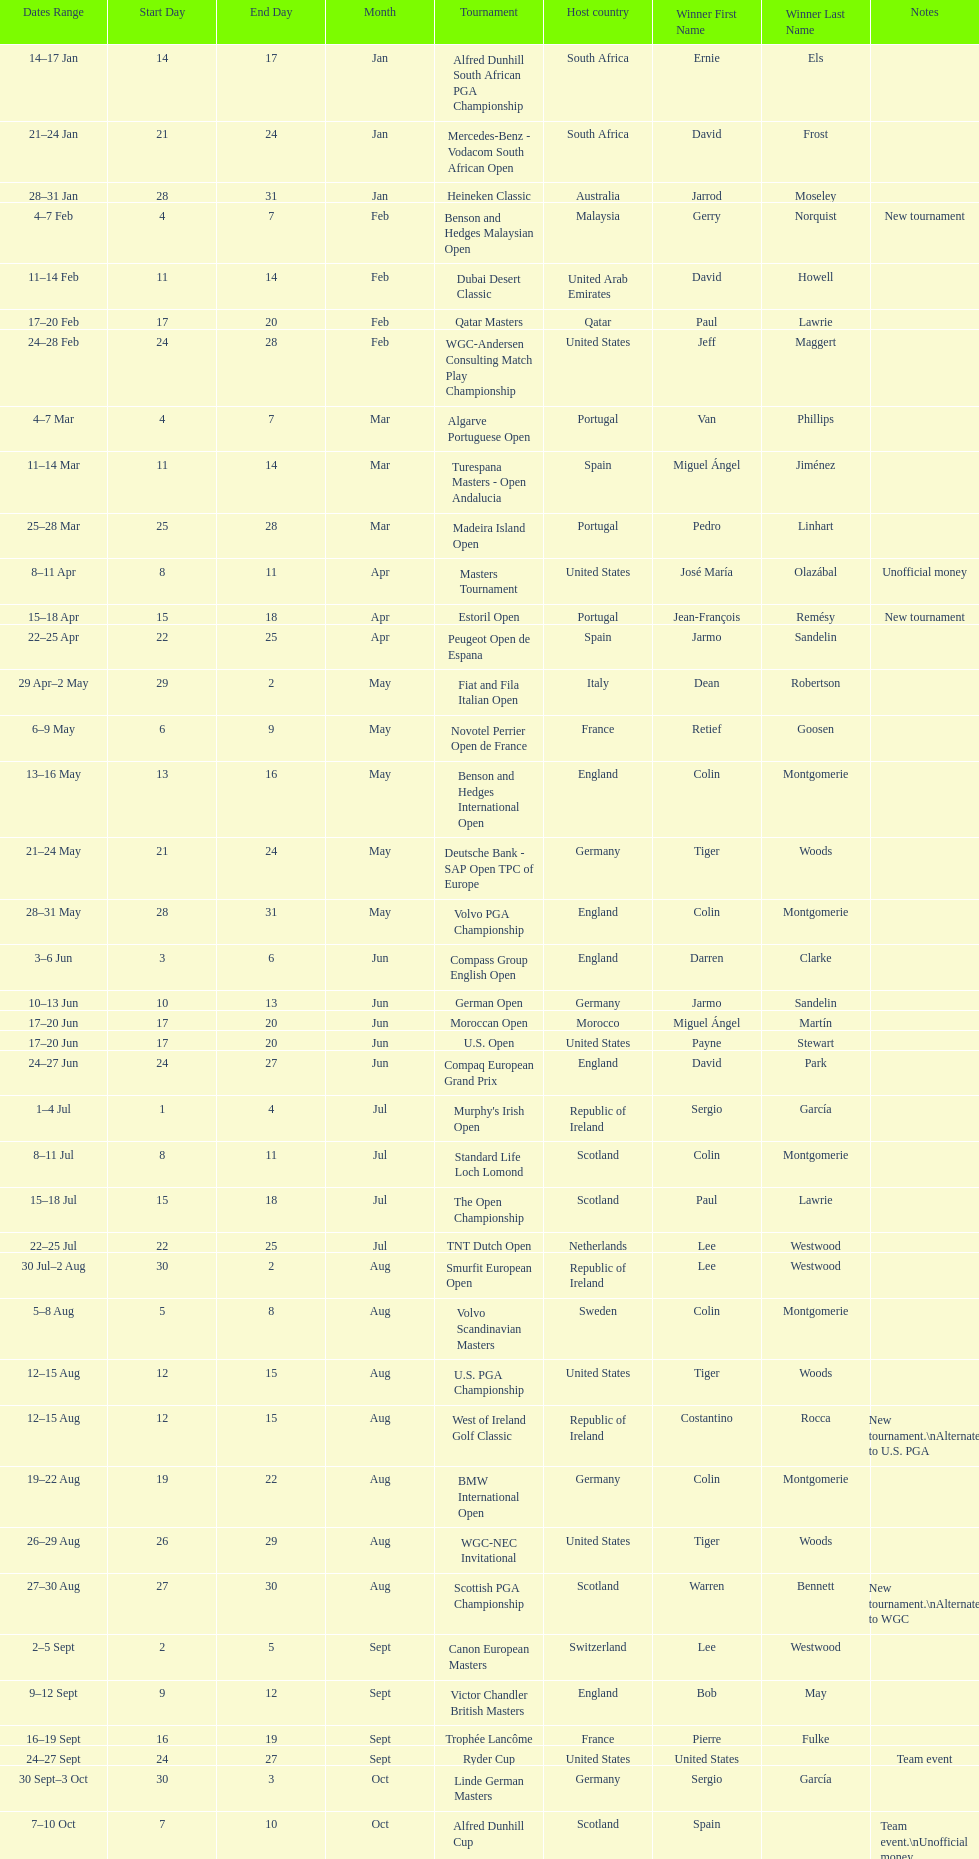How long did the estoril open last? 3 days. Help me parse the entirety of this table. {'header': ['Dates Range', 'Start Day', 'End Day', 'Month', 'Tournament', 'Host country', 'Winner First Name', 'Winner Last Name', 'Notes'], 'rows': [['14–17\xa0Jan', '14', '17', 'Jan', 'Alfred Dunhill South African PGA Championship', 'South Africa', 'Ernie', 'Els', ''], ['21–24\xa0Jan', '21', '24', 'Jan', 'Mercedes-Benz - Vodacom South African Open', 'South Africa', 'David', 'Frost', ''], ['28–31\xa0Jan', '28', '31', 'Jan', 'Heineken Classic', 'Australia', 'Jarrod', 'Moseley', ''], ['4–7\xa0Feb', '4', '7', 'Feb', 'Benson and Hedges Malaysian Open', 'Malaysia', 'Gerry', 'Norquist', 'New tournament'], ['11–14\xa0Feb', '11', '14', 'Feb', 'Dubai Desert Classic', 'United Arab Emirates', 'David', 'Howell', ''], ['17–20\xa0Feb', '17', '20', 'Feb', 'Qatar Masters', 'Qatar', 'Paul', 'Lawrie', ''], ['24–28\xa0Feb', '24', '28', 'Feb', 'WGC-Andersen Consulting Match Play Championship', 'United States', 'Jeff', 'Maggert', ''], ['4–7\xa0Mar', '4', '7', 'Mar', 'Algarve Portuguese Open', 'Portugal', 'Van', 'Phillips', ''], ['11–14\xa0Mar', '11', '14', 'Mar', 'Turespana Masters - Open Andalucia', 'Spain', 'Miguel Ángel', 'Jiménez', ''], ['25–28\xa0Mar', '25', '28', 'Mar', 'Madeira Island Open', 'Portugal', 'Pedro', 'Linhart', ''], ['8–11\xa0Apr', '8', '11', 'Apr', 'Masters Tournament', 'United States', 'José María', 'Olazábal', 'Unofficial money'], ['15–18\xa0Apr', '15', '18', 'Apr', 'Estoril Open', 'Portugal', 'Jean-François', 'Remésy', 'New tournament'], ['22–25\xa0Apr', '22', '25', 'Apr', 'Peugeot Open de Espana', 'Spain', 'Jarmo', 'Sandelin', ''], ['29\xa0Apr–2\xa0May', '29', '2', 'May', 'Fiat and Fila Italian Open', 'Italy', 'Dean', 'Robertson', ''], ['6–9\xa0May', '6', '9', 'May', 'Novotel Perrier Open de France', 'France', 'Retief', 'Goosen', ''], ['13–16\xa0May', '13', '16', 'May', 'Benson and Hedges International Open', 'England', 'Colin', 'Montgomerie', ''], ['21–24\xa0May', '21', '24', 'May', 'Deutsche Bank - SAP Open TPC of Europe', 'Germany', 'Tiger', 'Woods', ''], ['28–31\xa0May', '28', '31', 'May', 'Volvo PGA Championship', 'England', 'Colin', 'Montgomerie', ''], ['3–6\xa0Jun', '3', '6', 'Jun', 'Compass Group English Open', 'England', 'Darren', 'Clarke', ''], ['10–13\xa0Jun', '10', '13', 'Jun', 'German Open', 'Germany', 'Jarmo', 'Sandelin', ''], ['17–20\xa0Jun', '17', '20', 'Jun', 'Moroccan Open', 'Morocco', 'Miguel Ángel', 'Martín', ''], ['17–20\xa0Jun', '17', '20', 'Jun', 'U.S. Open', 'United States', 'Payne', 'Stewart', ''], ['24–27\xa0Jun', '24', '27', 'Jun', 'Compaq European Grand Prix', 'England', 'David', 'Park', ''], ['1–4\xa0Jul', '1', '4', 'Jul', "Murphy's Irish Open", 'Republic of Ireland', 'Sergio', 'García', ''], ['8–11\xa0Jul', '8', '11', 'Jul', 'Standard Life Loch Lomond', 'Scotland', 'Colin', 'Montgomerie', ''], ['15–18\xa0Jul', '15', '18', 'Jul', 'The Open Championship', 'Scotland', 'Paul', 'Lawrie', ''], ['22–25\xa0Jul', '22', '25', 'Jul', 'TNT Dutch Open', 'Netherlands', 'Lee', 'Westwood', ''], ['30\xa0Jul–2\xa0Aug', '30', '2', 'Aug', 'Smurfit European Open', 'Republic of Ireland', 'Lee', 'Westwood', ''], ['5–8\xa0Aug', '5', '8', 'Aug', 'Volvo Scandinavian Masters', 'Sweden', 'Colin', 'Montgomerie', ''], ['12–15\xa0Aug', '12', '15', 'Aug', 'U.S. PGA Championship', 'United States', 'Tiger', 'Woods', ''], ['12–15\xa0Aug', '12', '15', 'Aug', 'West of Ireland Golf Classic', 'Republic of Ireland', 'Costantino', 'Rocca', 'New tournament.\\nAlternate to U.S. PGA'], ['19–22\xa0Aug', '19', '22', 'Aug', 'BMW International Open', 'Germany', 'Colin', 'Montgomerie', ''], ['26–29\xa0Aug', '26', '29', 'Aug', 'WGC-NEC Invitational', 'United States', 'Tiger', 'Woods', ''], ['27–30\xa0Aug', '27', '30', 'Aug', 'Scottish PGA Championship', 'Scotland', 'Warren', 'Bennett', 'New tournament.\\nAlternate to WGC'], ['2–5\xa0Sept', '2', '5', 'Sept', 'Canon European Masters', 'Switzerland', 'Lee', 'Westwood', ''], ['9–12\xa0Sept', '9', '12', 'Sept', 'Victor Chandler British Masters', 'England', 'Bob', 'May', ''], ['16–19\xa0Sept', '16', '19', 'Sept', 'Trophée Lancôme', 'France', 'Pierre', 'Fulke', ''], ['24–27\xa0Sept', '24', '27', 'Sept', 'Ryder Cup', 'United States', 'United States', '', 'Team event'], ['30\xa0Sept–3\xa0Oct', '30', '3', 'Oct', 'Linde German Masters', 'Germany', 'Sergio', 'García', ''], ['7–10\xa0Oct', '7', '10', 'Oct', 'Alfred Dunhill Cup', 'Scotland', 'Spain', '', 'Team event.\\nUnofficial money'], ['14–17\xa0Oct', '14', '17', 'Oct', 'Cisco World Match Play Championship', 'England', 'Colin', 'Montgomerie', 'Unofficial money'], ['14–17\xa0Oct', '14', '17', 'Oct', 'Sarazen World Open', 'Spain', 'Thomas', 'Bjørn', 'New tournament'], ['21–24\xa0Oct', '21', '24', 'Oct', 'Belgacom Open', 'Belgium', 'Robert', 'Karlsson', ''], ['28–31\xa0Oct', '28', '31', 'Oct', 'Volvo Masters', 'Spain', 'Miguel Ángel', 'Jiménez', ''], ['4–7\xa0Nov', '4', '7', 'Nov', 'WGC-American Express Championship', 'Spain', 'Tiger', 'Woods', ''], ['18–21\xa0Nov', '18', '21', 'Nov', 'World Cup of Golf', 'Malaysia', 'United States', '', 'Team event.\\nUnofficial money']]} 